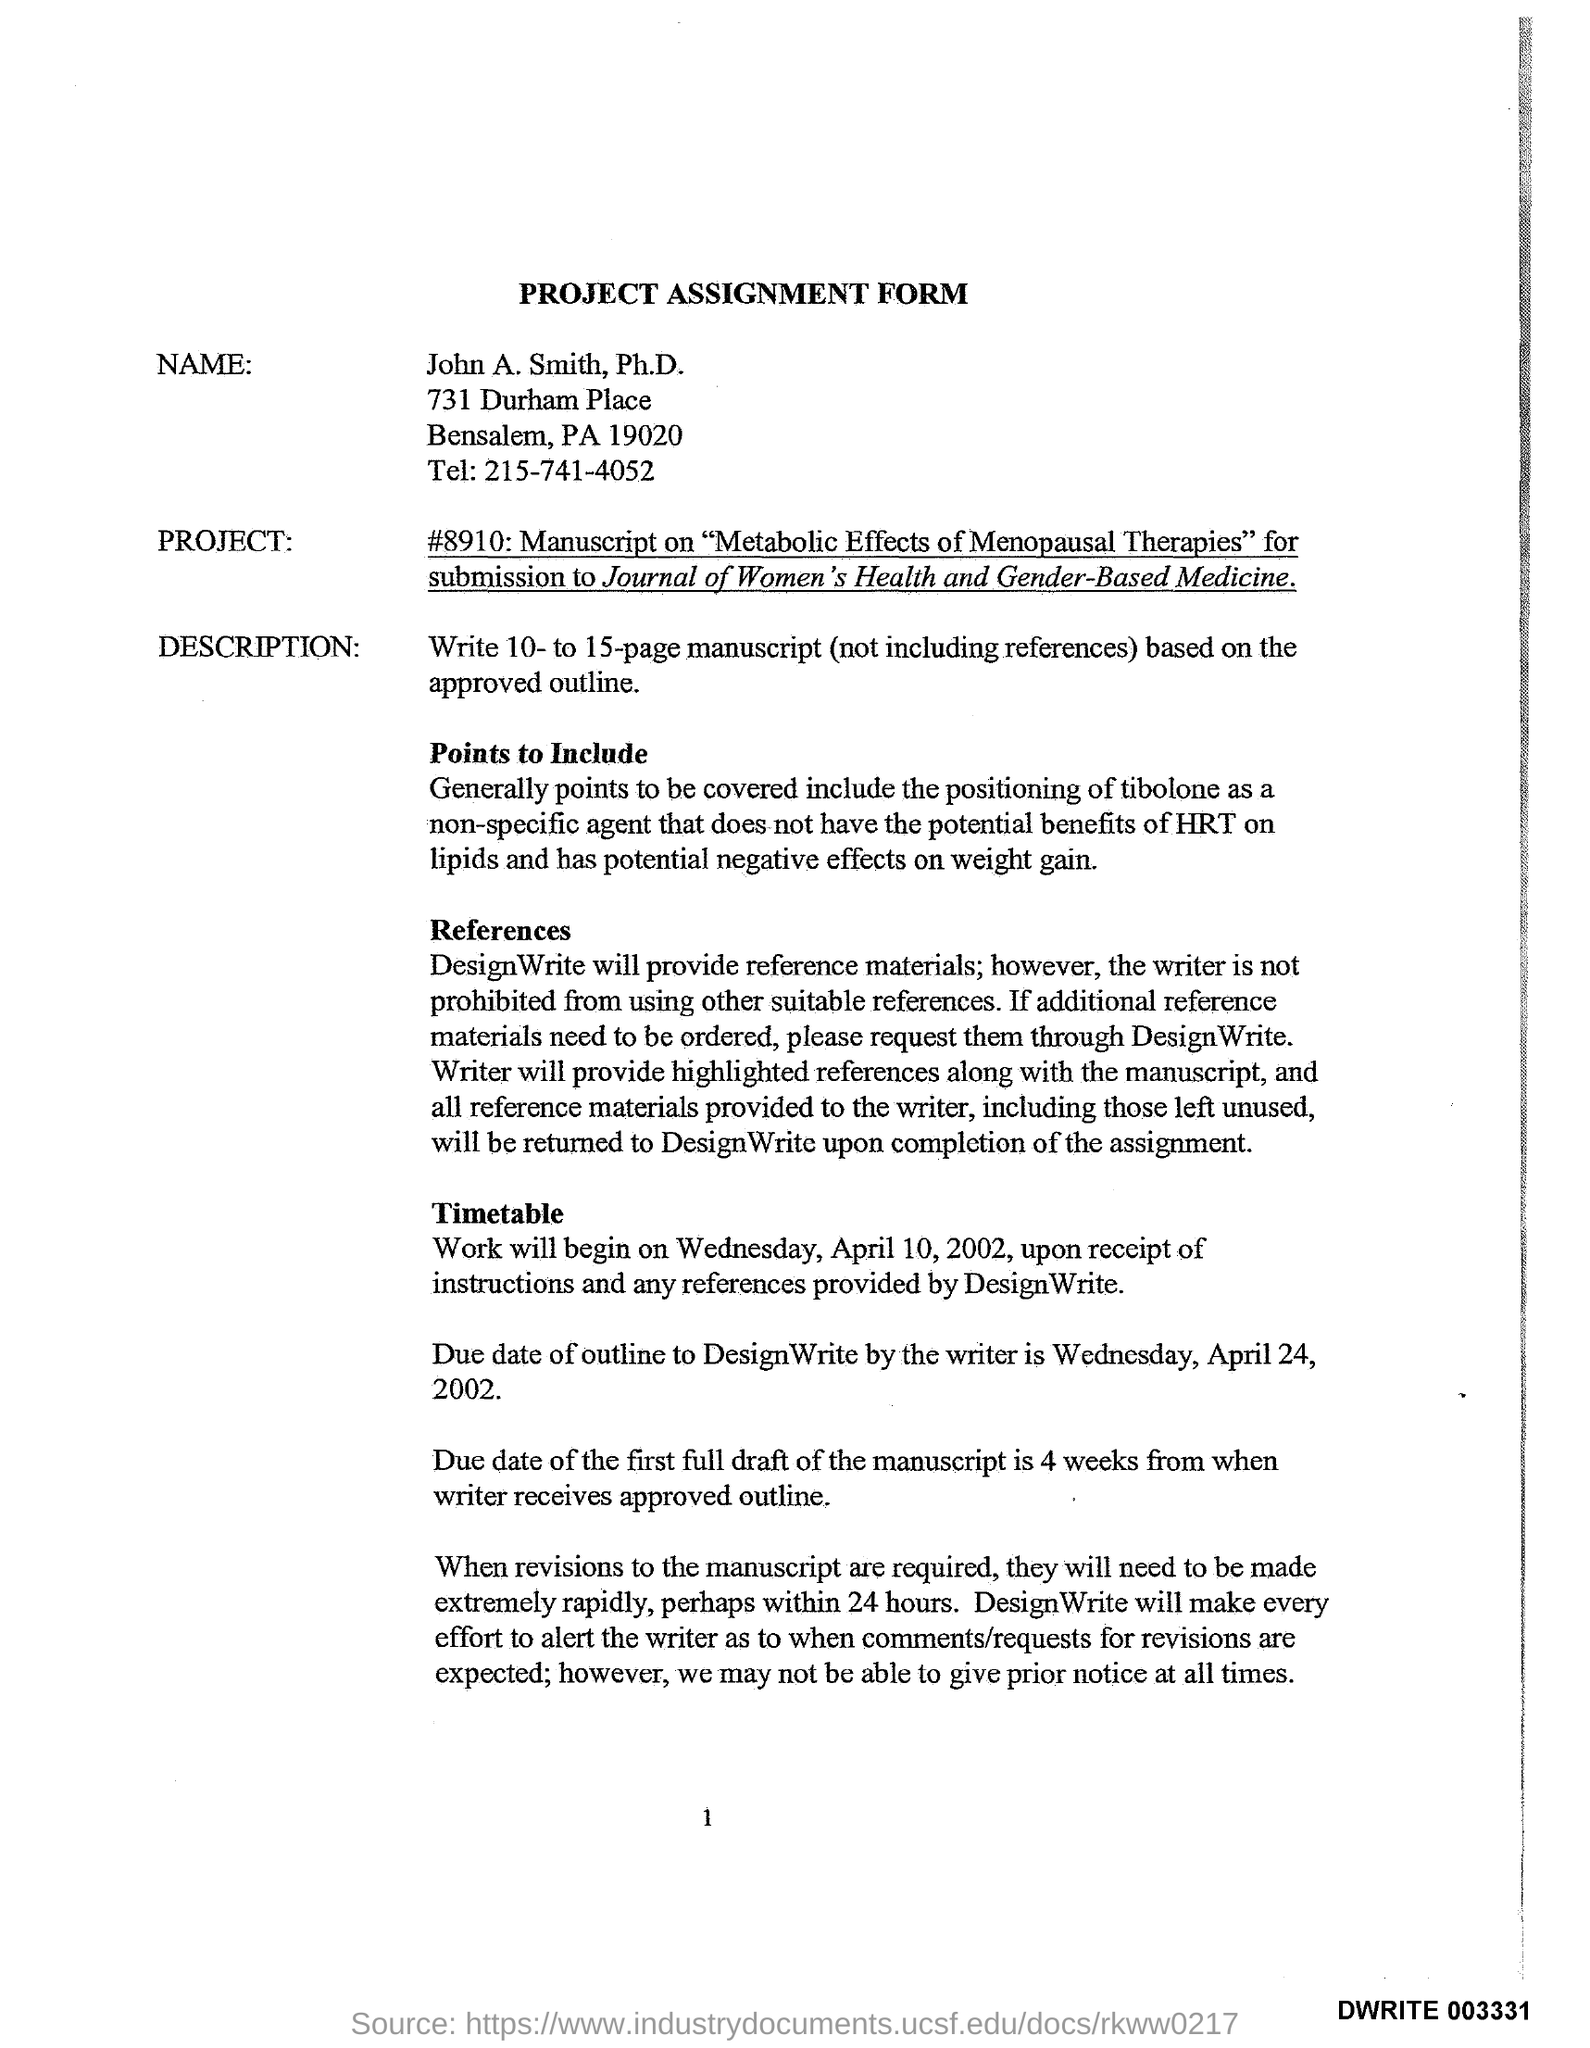What type of form is mentioned in this document ?
Make the answer very short. PROJECT ASSIGNMENT FORM. What is the Telephone Number ?
Your answer should be compact. 215-741-4052. What is the Name mentioned in the document ?
Make the answer very short. John A. Smith, Ph.D. 